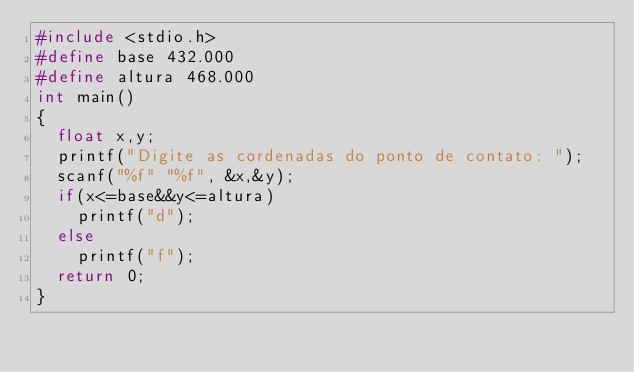<code> <loc_0><loc_0><loc_500><loc_500><_C_>#include <stdio.h>
#define base 432.000
#define altura 468.000
int main()
{
  float x,y;
  printf("Digite as cordenadas do ponto de contato: ");
  scanf("%f" "%f", &x,&y);
  if(x<=base&&y<=altura)
    printf("d");
  else
    printf("f");
  return 0;
}
</code> 